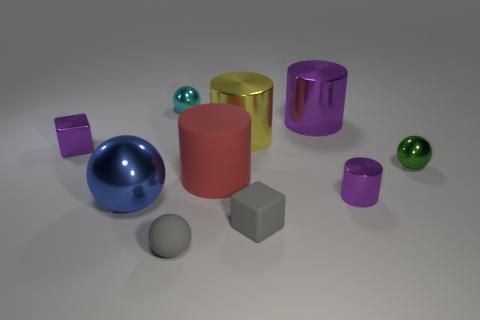Subtract all cyan spheres. How many spheres are left? 3 Subtract 1 cylinders. How many cylinders are left? 3 Subtract all red cylinders. How many cylinders are left? 3 Subtract all green cubes. How many cyan balls are left? 1 Subtract 0 green blocks. How many objects are left? 10 Subtract all cylinders. How many objects are left? 6 Subtract all cyan cylinders. Subtract all blue spheres. How many cylinders are left? 4 Subtract all tiny gray rubber things. Subtract all big blue spheres. How many objects are left? 7 Add 7 big purple things. How many big purple things are left? 8 Add 6 big blue metallic objects. How many big blue metallic objects exist? 7 